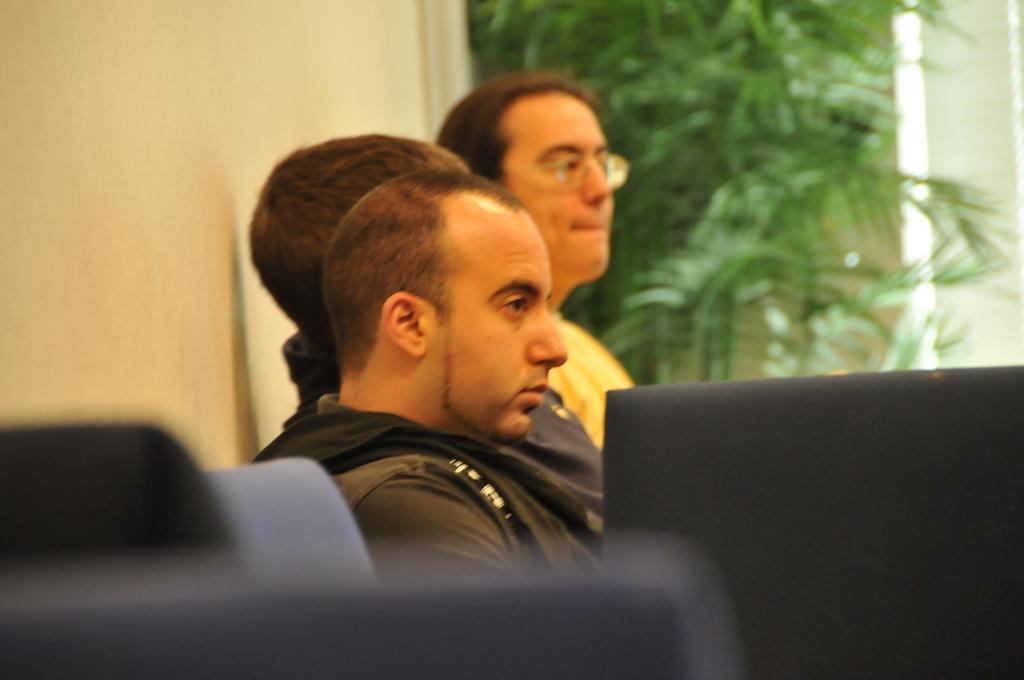Describe this image in one or two sentences. Here in this picture we can see a group of people sitting over a place and in the front we can see chairs present and behind them we can see plants present over there. 